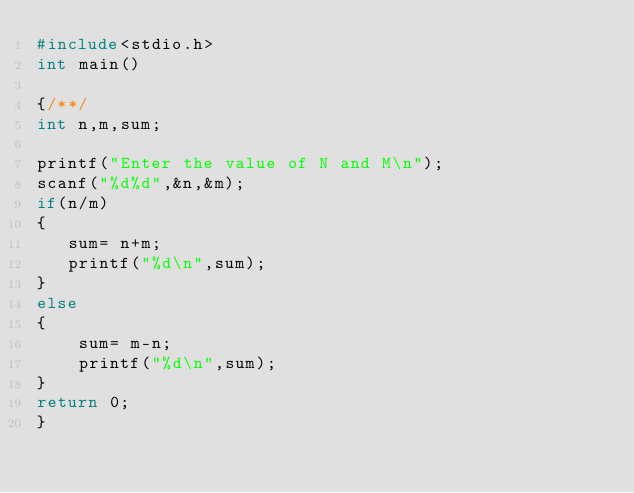<code> <loc_0><loc_0><loc_500><loc_500><_C_>#include<stdio.h>
int main()

{/**/
int n,m,sum;

printf("Enter the value of N and M\n");
scanf("%d%d",&n,&m);
if(n/m)
{
   sum= n+m;
   printf("%d\n",sum);
}
else
{
    sum= m-n;
    printf("%d\n",sum);
}
return 0;
}</code> 